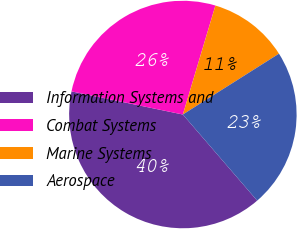Convert chart to OTSL. <chart><loc_0><loc_0><loc_500><loc_500><pie_chart><fcel>Information Systems and<fcel>Combat Systems<fcel>Marine Systems<fcel>Aerospace<nl><fcel>39.59%<fcel>26.36%<fcel>11.4%<fcel>22.65%<nl></chart> 